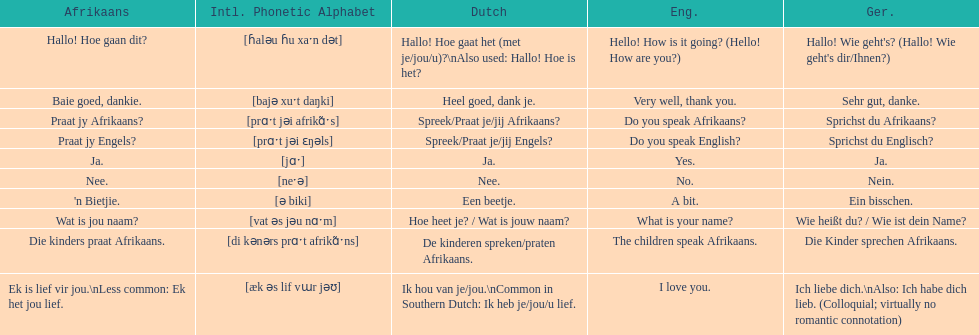What is the translation of "do you speak afrikaans?" in afrikaans? Praat jy Afrikaans?. 